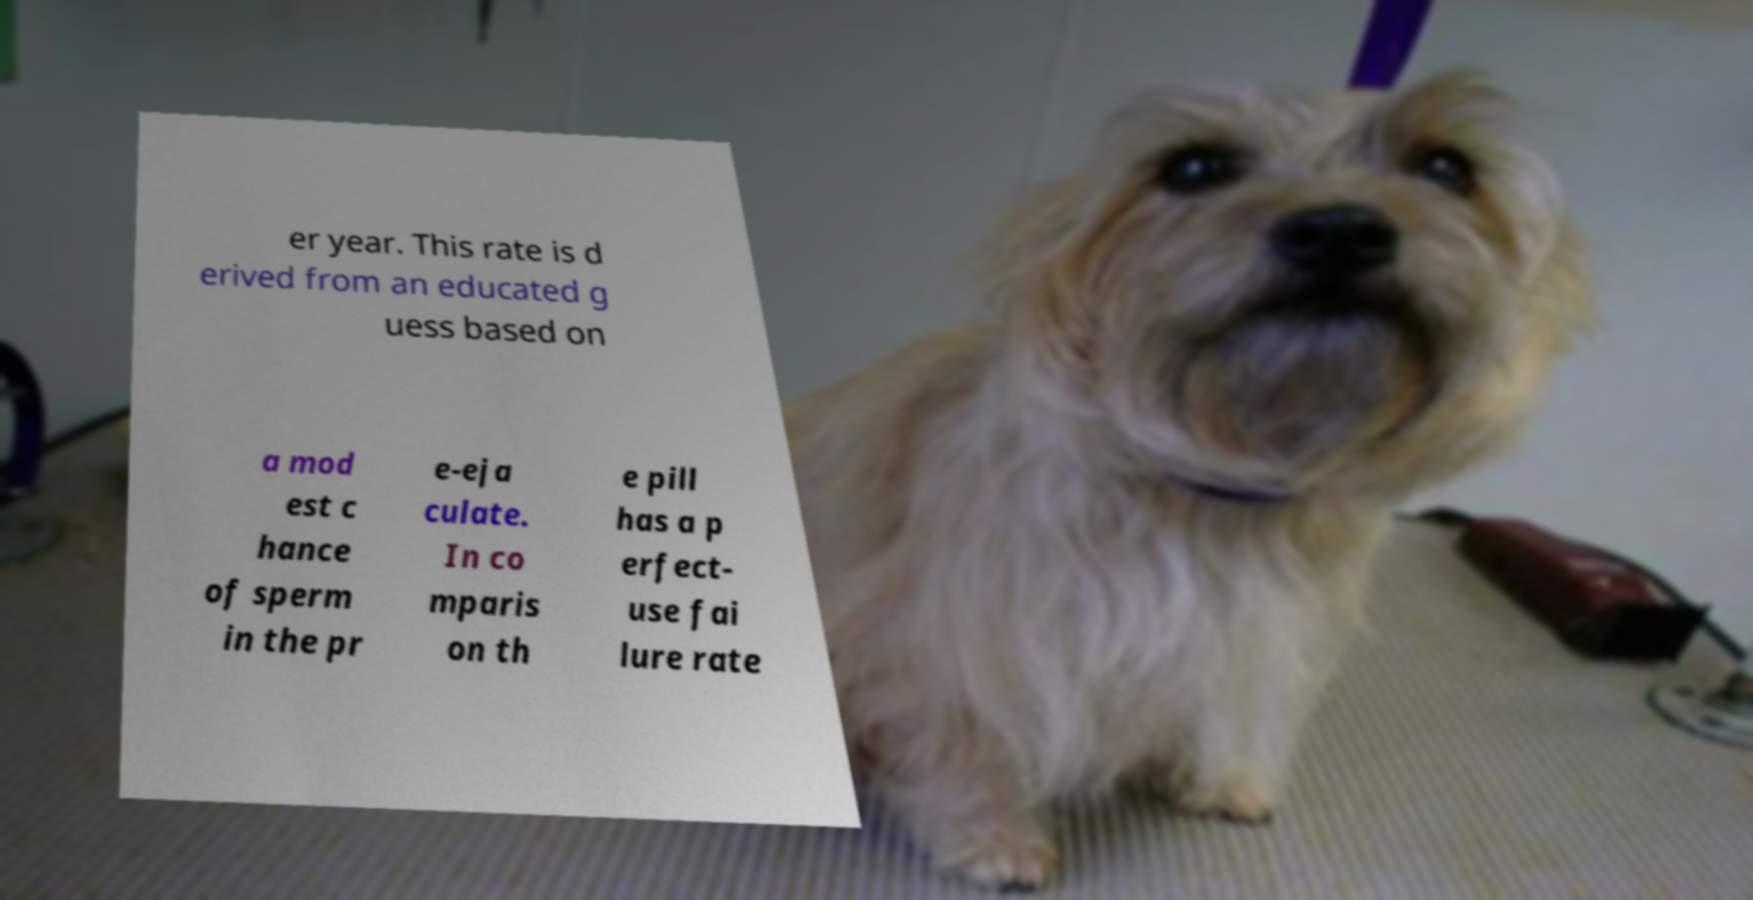There's text embedded in this image that I need extracted. Can you transcribe it verbatim? er year. This rate is d erived from an educated g uess based on a mod est c hance of sperm in the pr e-eja culate. In co mparis on th e pill has a p erfect- use fai lure rate 